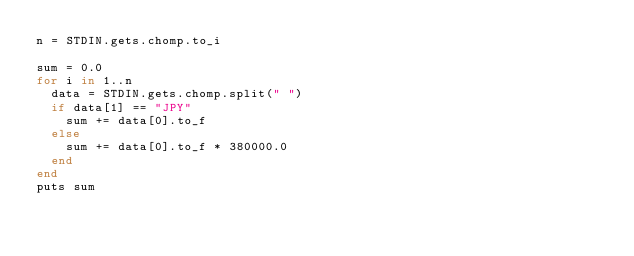<code> <loc_0><loc_0><loc_500><loc_500><_Ruby_>n = STDIN.gets.chomp.to_i

sum = 0.0
for i in 1..n
  data = STDIN.gets.chomp.split(" ")
  if data[1] == "JPY"
    sum += data[0].to_f
  else
    sum += data[0].to_f * 380000.0
  end
end
puts sum</code> 